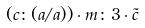<formula> <loc_0><loc_0><loc_500><loc_500>( c \colon ( a / a ) ) \cdot m \colon 3 \cdot \tilde { c }</formula> 